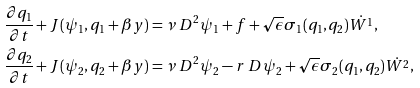<formula> <loc_0><loc_0><loc_500><loc_500>\frac { \partial q _ { 1 } } { \partial t } + J ( \psi _ { 1 } , q _ { 1 } + \beta y ) & = \nu \ D ^ { 2 } \psi _ { 1 } + f + \sqrt { \epsilon } \sigma _ { 1 } ( q _ { 1 } , q _ { 2 } ) \dot { W ^ { 1 } } , \\ \frac { \partial q _ { 2 } } { \partial t } + J ( \psi _ { 2 } , q _ { 2 } + \beta y ) & = \nu \ D ^ { 2 } \psi _ { 2 } - r \ D \psi _ { 2 } + \sqrt { \epsilon } \sigma _ { 2 } ( q _ { 1 } , q _ { 2 } ) \dot { W ^ { 2 } } ,</formula> 